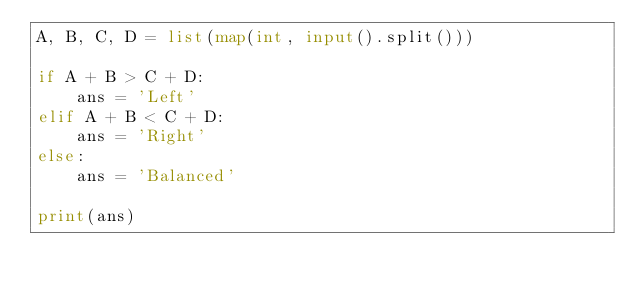Convert code to text. <code><loc_0><loc_0><loc_500><loc_500><_Python_>A, B, C, D = list(map(int, input().split()))

if A + B > C + D:
    ans = 'Left'
elif A + B < C + D:
    ans = 'Right'
else:
    ans = 'Balanced'

print(ans)</code> 